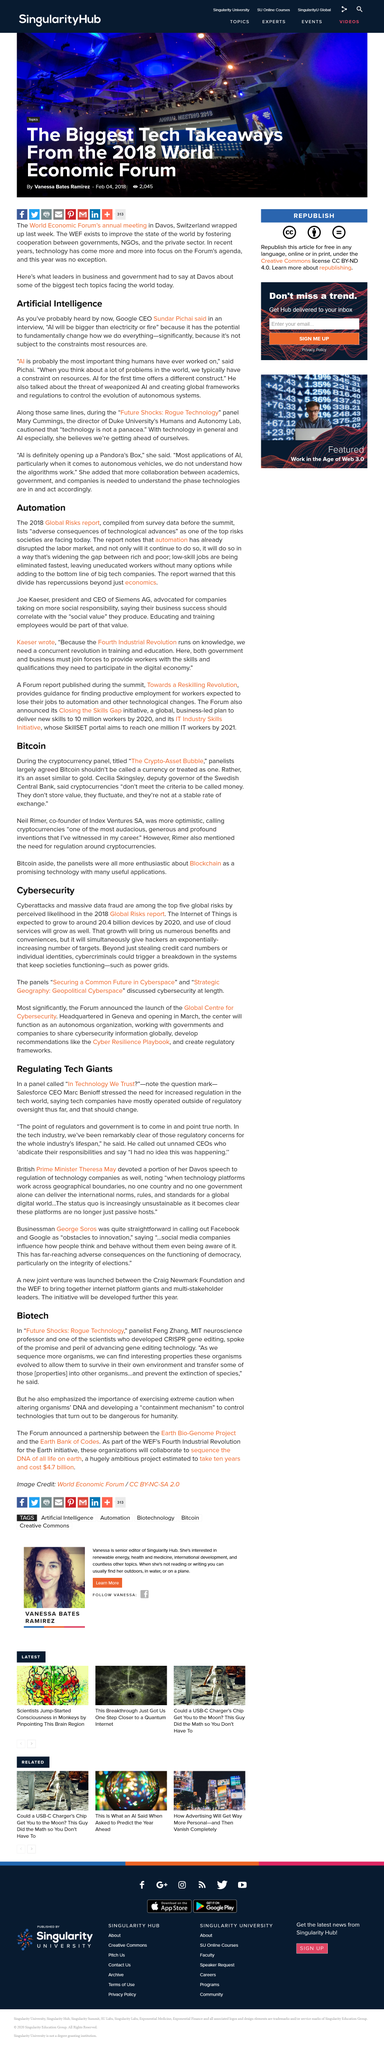Draw attention to some important aspects in this diagram. The 2018 global risks report is compiled of survey data that was collected in the year 2018. Neil Rimer is the co-founder of Index Ventures SA, a company known for its successful investments in technology startups. Marc Benioff, CEO of Salesforce, stated in the panel called "In Technology We Trust" that there is a need for increased regulation in the tech world, as tech companies have largely operated outside of regulatory oversight until now. Feng Zhang, a prominent neuroscience professor at MIT, is mentioned in the article. Automation has already had a significant impact on the labor market and will continue to do so, exacerbating the wealth divide between the rich and poor. 